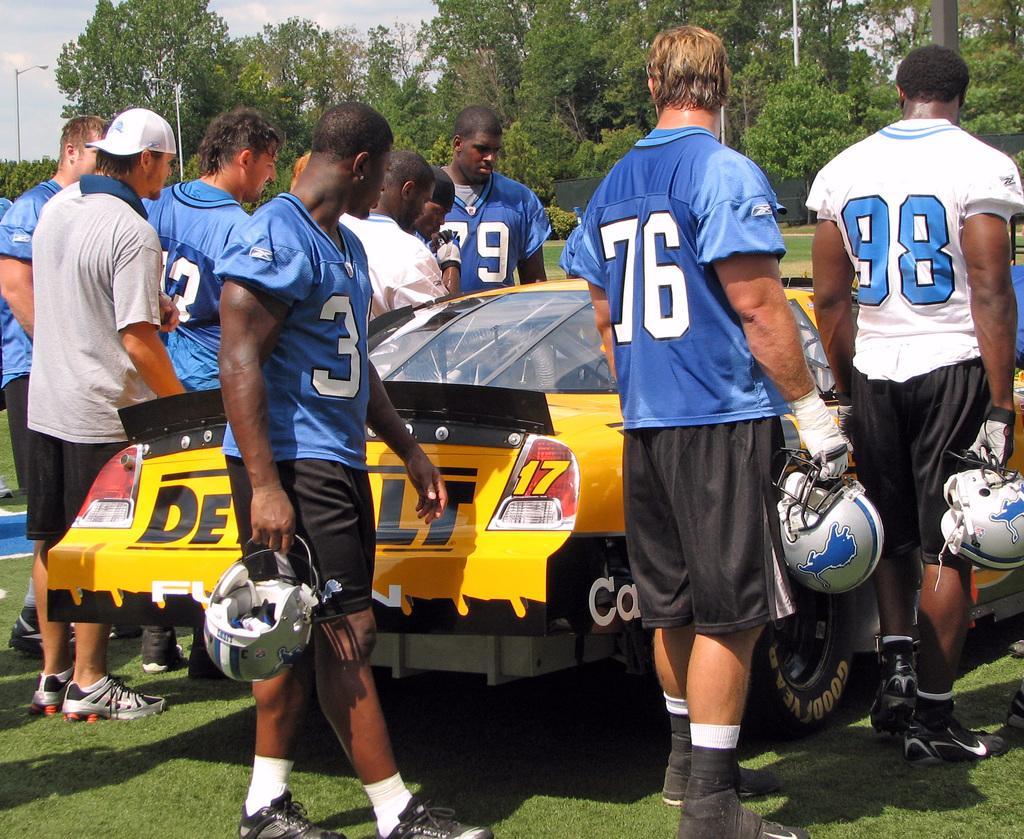Please provide a concise description of this image. In the foreground of the picture there are people, car and grass. In the background there are trees, plants, black curtain and street lights. At the top there is sky. 